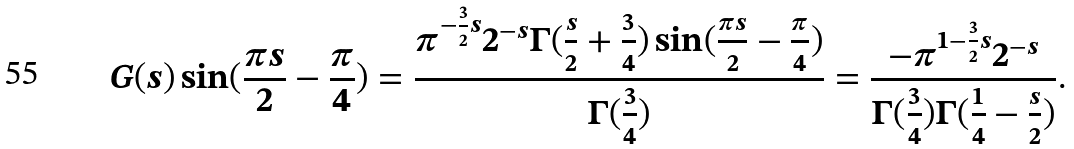<formula> <loc_0><loc_0><loc_500><loc_500>G ( s ) \sin ( \frac { \pi s } { 2 } - \frac { \pi } { 4 } ) = \frac { \pi ^ { - \frac { 3 } { 2 } s } 2 ^ { - s } \Gamma ( \frac { s } { 2 } + \frac { 3 } { 4 } ) \sin ( \frac { \pi s } { 2 } - \frac { \pi } { 4 } ) } { \Gamma ( \frac { 3 } { 4 } ) } = \frac { - \pi ^ { 1 - \frac { 3 } { 2 } s } 2 ^ { - s } } { \Gamma ( \frac { 3 } { 4 } ) \Gamma ( \frac { 1 } { 4 } - \frac { s } { 2 } ) } .</formula> 